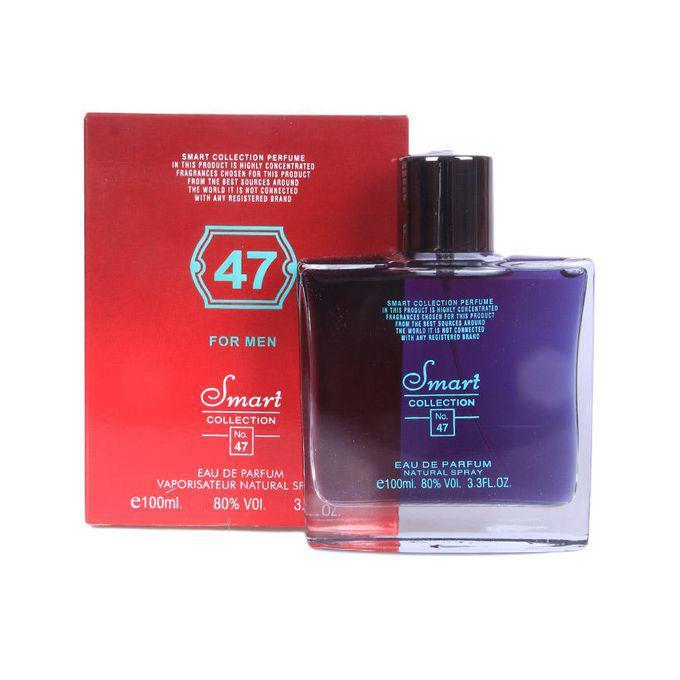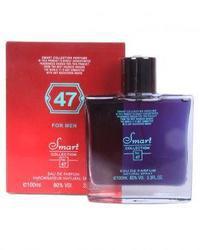The first image is the image on the left, the second image is the image on the right. Assess this claim about the two images: "The  glass perfume bottle furthest to the right in the right image is purple.". Correct or not? Answer yes or no. Yes. 